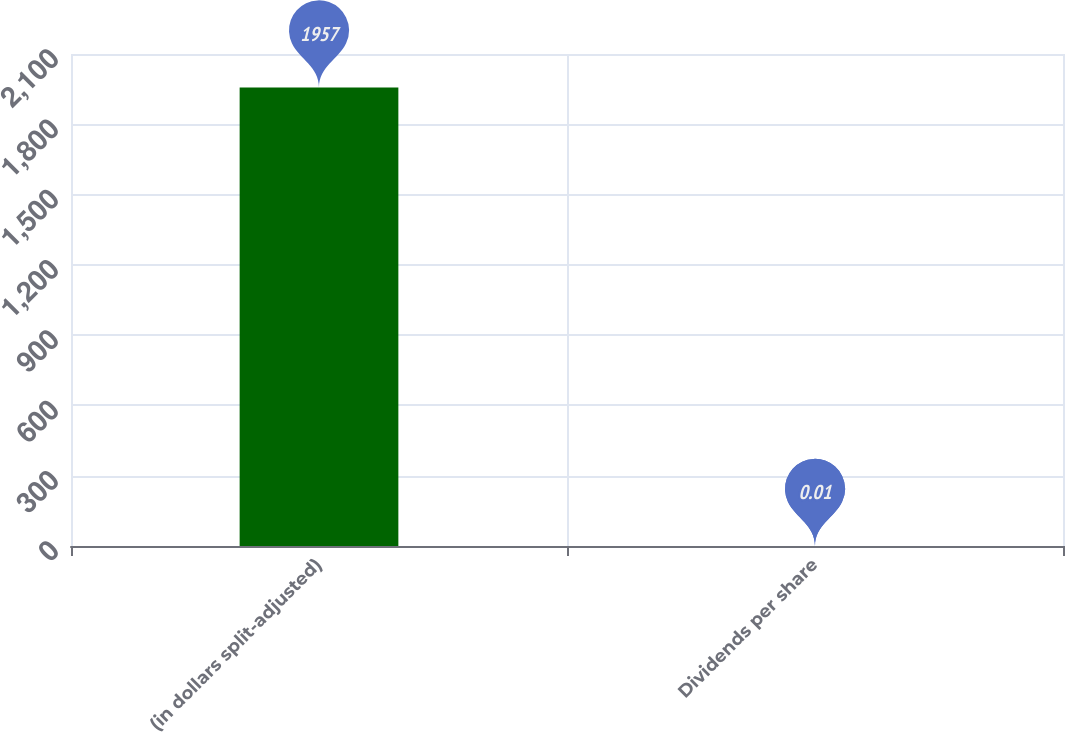Convert chart to OTSL. <chart><loc_0><loc_0><loc_500><loc_500><bar_chart><fcel>(in dollars split-adjusted)<fcel>Dividends per share<nl><fcel>1957<fcel>0.01<nl></chart> 